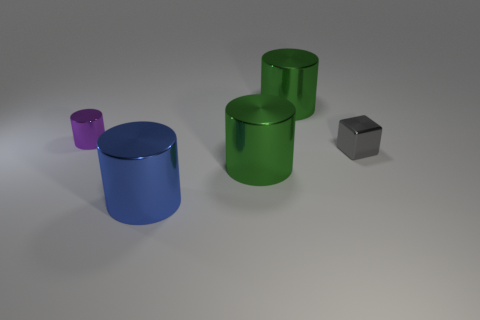How many things are either cylinders that are on the left side of the blue metallic cylinder or green metal objects that are in front of the purple shiny thing?
Ensure brevity in your answer.  2. What is the shape of the small purple object that is the same material as the small cube?
Give a very brief answer. Cylinder. What number of green metallic balls are there?
Give a very brief answer. 0. What number of objects are either tiny things that are behind the metallic block or small cylinders?
Your answer should be compact. 1. How many other objects are the same color as the tiny metal cylinder?
Keep it short and to the point. 0. How many big things are either metal things or blue shiny things?
Offer a terse response. 3. Are there more small purple cylinders than small green shiny things?
Your response must be concise. Yes. Is there any other thing that has the same material as the gray block?
Provide a succinct answer. Yes. Are there more big green metal objects behind the gray block than tiny brown metallic balls?
Your response must be concise. Yes. Does the tiny metal block have the same color as the tiny shiny cylinder?
Keep it short and to the point. No. 